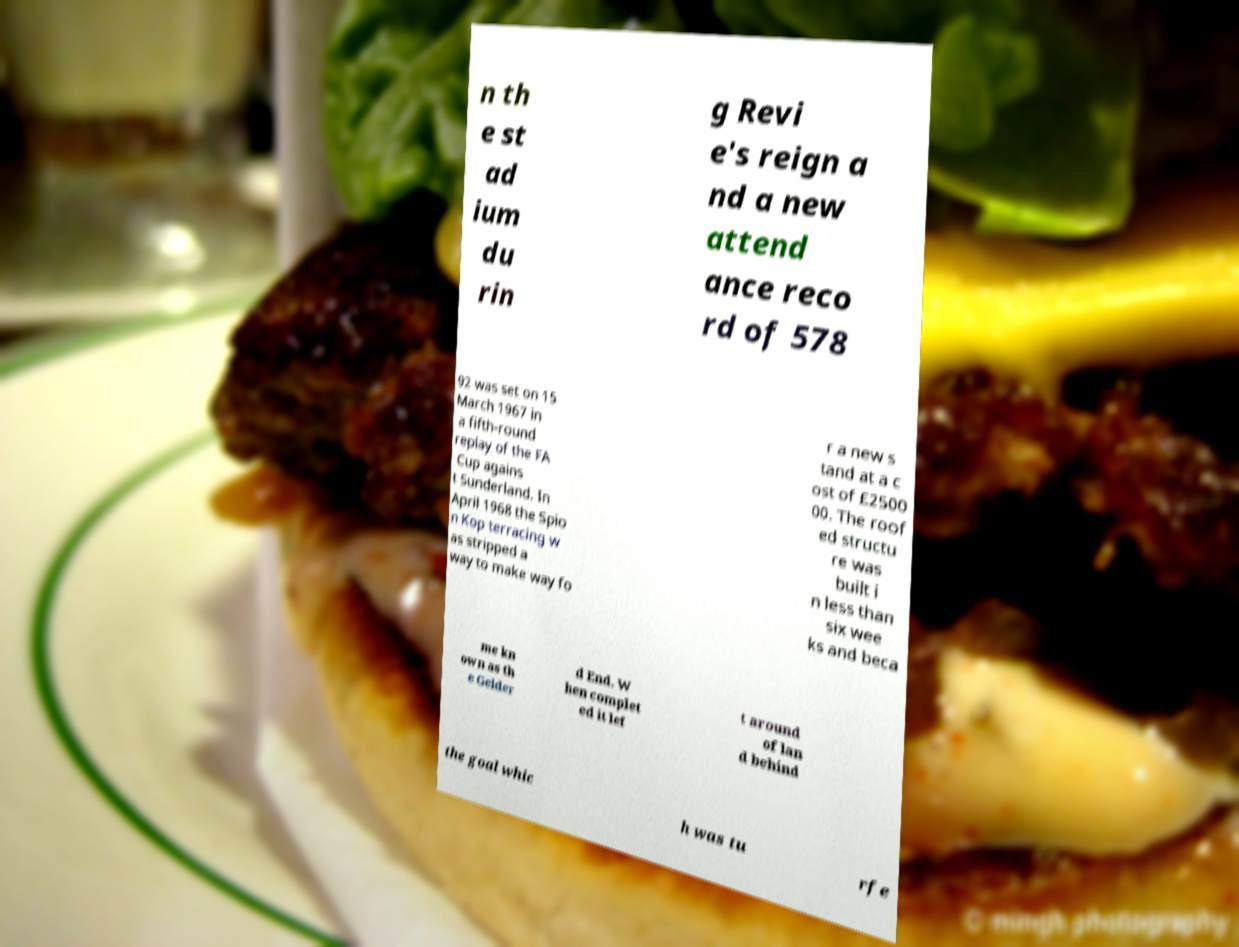For documentation purposes, I need the text within this image transcribed. Could you provide that? n th e st ad ium du rin g Revi e's reign a nd a new attend ance reco rd of 578 92 was set on 15 March 1967 in a fifth-round replay of the FA Cup agains t Sunderland. In April 1968 the Spio n Kop terracing w as stripped a way to make way fo r a new s tand at a c ost of £2500 00. The roof ed structu re was built i n less than six wee ks and beca me kn own as th e Gelder d End. W hen complet ed it lef t around of lan d behind the goal whic h was tu rfe 